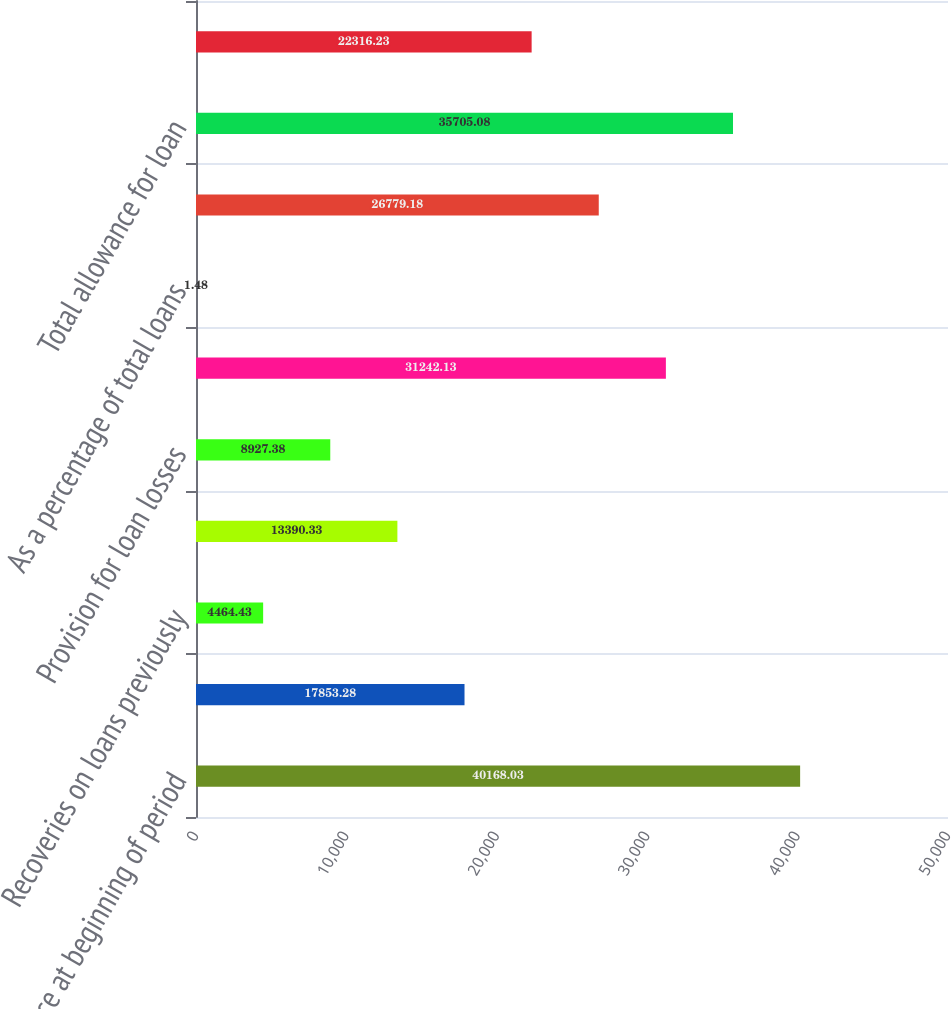Convert chart. <chart><loc_0><loc_0><loc_500><loc_500><bar_chart><fcel>Balance at beginning of period<fcel>Loan charge-offs<fcel>Recoveries on loans previously<fcel>Net loan (charge-offs)<fcel>Provision for loan losses<fcel>Balance at end of period<fcel>As a percentage of total loans<fcel>Collectively evaluated for<fcel>Total allowance for loan<fcel>Individually evaluated for<nl><fcel>40168<fcel>17853.3<fcel>4464.43<fcel>13390.3<fcel>8927.38<fcel>31242.1<fcel>1.48<fcel>26779.2<fcel>35705.1<fcel>22316.2<nl></chart> 